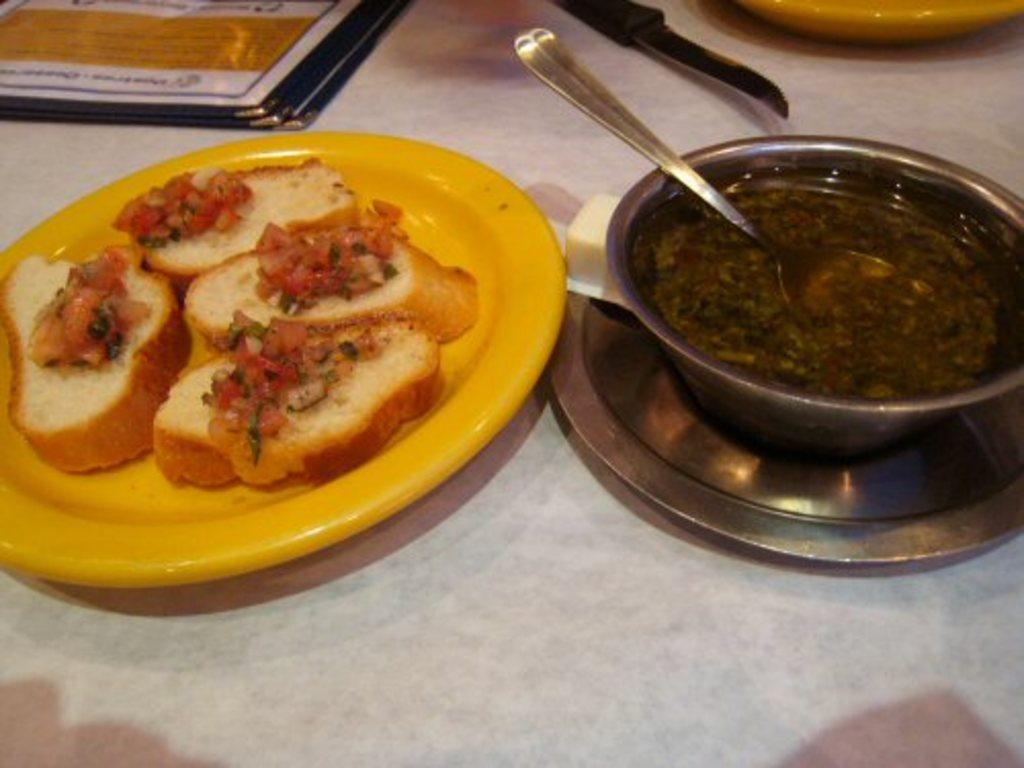What color is the plate that is visible in the image? There is a yellow plate in the image. What is on the plate in the image? Bread slices and vegetables are present on the plate. What else can be seen in the image besides the plate? There is a bowl with some food item in the image. What type of snake can be seen slithering on the plate in the image? There is no snake present on the plate or in the image. Is there a notebook visible in the image? No, there is no notebook present in the image. 